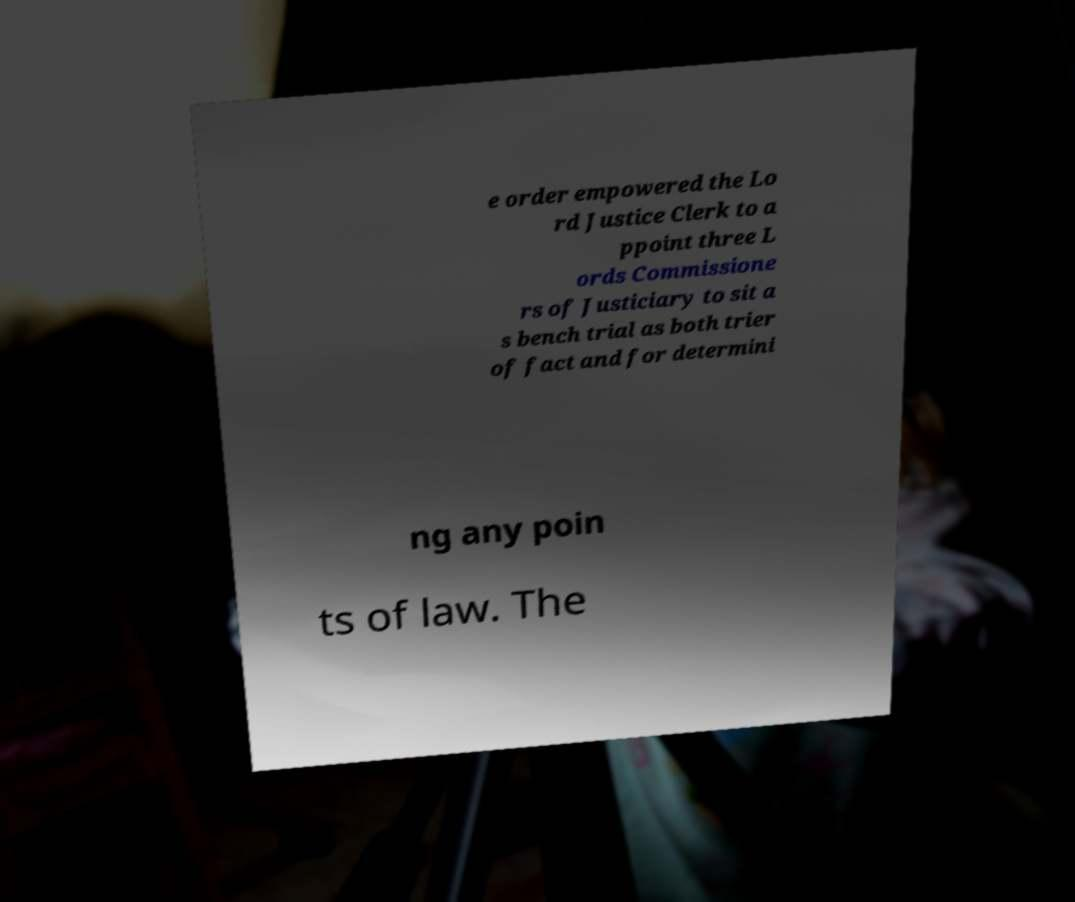For documentation purposes, I need the text within this image transcribed. Could you provide that? e order empowered the Lo rd Justice Clerk to a ppoint three L ords Commissione rs of Justiciary to sit a s bench trial as both trier of fact and for determini ng any poin ts of law. The 